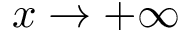Convert formula to latex. <formula><loc_0><loc_0><loc_500><loc_500>x \to + \infty</formula> 